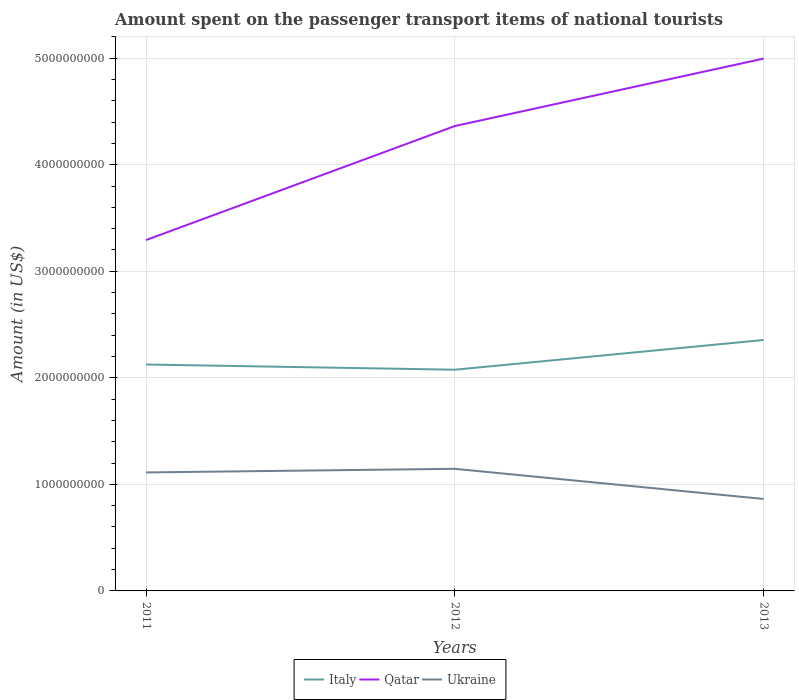How many different coloured lines are there?
Your answer should be very brief. 3. Does the line corresponding to Ukraine intersect with the line corresponding to Italy?
Your answer should be compact. No. Across all years, what is the maximum amount spent on the passenger transport items of national tourists in Ukraine?
Provide a succinct answer. 8.63e+08. What is the total amount spent on the passenger transport items of national tourists in Italy in the graph?
Offer a very short reply. -2.30e+08. What is the difference between the highest and the second highest amount spent on the passenger transport items of national tourists in Italy?
Offer a very short reply. 2.79e+08. What is the difference between the highest and the lowest amount spent on the passenger transport items of national tourists in Italy?
Keep it short and to the point. 1. How many lines are there?
Offer a very short reply. 3. Does the graph contain any zero values?
Offer a very short reply. No. How many legend labels are there?
Your answer should be very brief. 3. What is the title of the graph?
Give a very brief answer. Amount spent on the passenger transport items of national tourists. What is the label or title of the X-axis?
Your answer should be compact. Years. What is the Amount (in US$) in Italy in 2011?
Your answer should be compact. 2.12e+09. What is the Amount (in US$) in Qatar in 2011?
Keep it short and to the point. 3.29e+09. What is the Amount (in US$) of Ukraine in 2011?
Make the answer very short. 1.11e+09. What is the Amount (in US$) in Italy in 2012?
Ensure brevity in your answer.  2.08e+09. What is the Amount (in US$) in Qatar in 2012?
Ensure brevity in your answer.  4.36e+09. What is the Amount (in US$) of Ukraine in 2012?
Offer a very short reply. 1.15e+09. What is the Amount (in US$) in Italy in 2013?
Offer a terse response. 2.36e+09. What is the Amount (in US$) of Qatar in 2013?
Offer a very short reply. 5.00e+09. What is the Amount (in US$) of Ukraine in 2013?
Your answer should be compact. 8.63e+08. Across all years, what is the maximum Amount (in US$) of Italy?
Provide a succinct answer. 2.36e+09. Across all years, what is the maximum Amount (in US$) in Qatar?
Ensure brevity in your answer.  5.00e+09. Across all years, what is the maximum Amount (in US$) in Ukraine?
Offer a terse response. 1.15e+09. Across all years, what is the minimum Amount (in US$) in Italy?
Make the answer very short. 2.08e+09. Across all years, what is the minimum Amount (in US$) of Qatar?
Make the answer very short. 3.29e+09. Across all years, what is the minimum Amount (in US$) of Ukraine?
Keep it short and to the point. 8.63e+08. What is the total Amount (in US$) of Italy in the graph?
Give a very brief answer. 6.56e+09. What is the total Amount (in US$) in Qatar in the graph?
Provide a succinct answer. 1.27e+1. What is the total Amount (in US$) of Ukraine in the graph?
Keep it short and to the point. 3.12e+09. What is the difference between the Amount (in US$) of Italy in 2011 and that in 2012?
Ensure brevity in your answer.  4.90e+07. What is the difference between the Amount (in US$) in Qatar in 2011 and that in 2012?
Make the answer very short. -1.07e+09. What is the difference between the Amount (in US$) of Ukraine in 2011 and that in 2012?
Your response must be concise. -3.40e+07. What is the difference between the Amount (in US$) in Italy in 2011 and that in 2013?
Make the answer very short. -2.30e+08. What is the difference between the Amount (in US$) in Qatar in 2011 and that in 2013?
Offer a very short reply. -1.70e+09. What is the difference between the Amount (in US$) in Ukraine in 2011 and that in 2013?
Ensure brevity in your answer.  2.49e+08. What is the difference between the Amount (in US$) in Italy in 2012 and that in 2013?
Give a very brief answer. -2.79e+08. What is the difference between the Amount (in US$) of Qatar in 2012 and that in 2013?
Provide a short and direct response. -6.33e+08. What is the difference between the Amount (in US$) in Ukraine in 2012 and that in 2013?
Make the answer very short. 2.83e+08. What is the difference between the Amount (in US$) of Italy in 2011 and the Amount (in US$) of Qatar in 2012?
Make the answer very short. -2.24e+09. What is the difference between the Amount (in US$) of Italy in 2011 and the Amount (in US$) of Ukraine in 2012?
Your answer should be very brief. 9.79e+08. What is the difference between the Amount (in US$) in Qatar in 2011 and the Amount (in US$) in Ukraine in 2012?
Keep it short and to the point. 2.15e+09. What is the difference between the Amount (in US$) of Italy in 2011 and the Amount (in US$) of Qatar in 2013?
Keep it short and to the point. -2.87e+09. What is the difference between the Amount (in US$) in Italy in 2011 and the Amount (in US$) in Ukraine in 2013?
Your answer should be compact. 1.26e+09. What is the difference between the Amount (in US$) of Qatar in 2011 and the Amount (in US$) of Ukraine in 2013?
Offer a terse response. 2.43e+09. What is the difference between the Amount (in US$) of Italy in 2012 and the Amount (in US$) of Qatar in 2013?
Keep it short and to the point. -2.92e+09. What is the difference between the Amount (in US$) of Italy in 2012 and the Amount (in US$) of Ukraine in 2013?
Keep it short and to the point. 1.21e+09. What is the difference between the Amount (in US$) of Qatar in 2012 and the Amount (in US$) of Ukraine in 2013?
Offer a terse response. 3.50e+09. What is the average Amount (in US$) of Italy per year?
Provide a succinct answer. 2.19e+09. What is the average Amount (in US$) in Qatar per year?
Offer a very short reply. 4.22e+09. What is the average Amount (in US$) of Ukraine per year?
Your answer should be compact. 1.04e+09. In the year 2011, what is the difference between the Amount (in US$) in Italy and Amount (in US$) in Qatar?
Provide a short and direct response. -1.17e+09. In the year 2011, what is the difference between the Amount (in US$) in Italy and Amount (in US$) in Ukraine?
Provide a short and direct response. 1.01e+09. In the year 2011, what is the difference between the Amount (in US$) of Qatar and Amount (in US$) of Ukraine?
Keep it short and to the point. 2.18e+09. In the year 2012, what is the difference between the Amount (in US$) in Italy and Amount (in US$) in Qatar?
Your answer should be compact. -2.29e+09. In the year 2012, what is the difference between the Amount (in US$) in Italy and Amount (in US$) in Ukraine?
Give a very brief answer. 9.30e+08. In the year 2012, what is the difference between the Amount (in US$) of Qatar and Amount (in US$) of Ukraine?
Your answer should be compact. 3.22e+09. In the year 2013, what is the difference between the Amount (in US$) in Italy and Amount (in US$) in Qatar?
Your answer should be compact. -2.64e+09. In the year 2013, what is the difference between the Amount (in US$) in Italy and Amount (in US$) in Ukraine?
Keep it short and to the point. 1.49e+09. In the year 2013, what is the difference between the Amount (in US$) of Qatar and Amount (in US$) of Ukraine?
Make the answer very short. 4.13e+09. What is the ratio of the Amount (in US$) in Italy in 2011 to that in 2012?
Your answer should be very brief. 1.02. What is the ratio of the Amount (in US$) in Qatar in 2011 to that in 2012?
Ensure brevity in your answer.  0.75. What is the ratio of the Amount (in US$) in Ukraine in 2011 to that in 2012?
Provide a short and direct response. 0.97. What is the ratio of the Amount (in US$) of Italy in 2011 to that in 2013?
Offer a terse response. 0.9. What is the ratio of the Amount (in US$) in Qatar in 2011 to that in 2013?
Keep it short and to the point. 0.66. What is the ratio of the Amount (in US$) in Ukraine in 2011 to that in 2013?
Your answer should be compact. 1.29. What is the ratio of the Amount (in US$) of Italy in 2012 to that in 2013?
Your answer should be very brief. 0.88. What is the ratio of the Amount (in US$) in Qatar in 2012 to that in 2013?
Keep it short and to the point. 0.87. What is the ratio of the Amount (in US$) of Ukraine in 2012 to that in 2013?
Offer a very short reply. 1.33. What is the difference between the highest and the second highest Amount (in US$) in Italy?
Your response must be concise. 2.30e+08. What is the difference between the highest and the second highest Amount (in US$) in Qatar?
Your response must be concise. 6.33e+08. What is the difference between the highest and the second highest Amount (in US$) of Ukraine?
Offer a terse response. 3.40e+07. What is the difference between the highest and the lowest Amount (in US$) in Italy?
Keep it short and to the point. 2.79e+08. What is the difference between the highest and the lowest Amount (in US$) of Qatar?
Provide a succinct answer. 1.70e+09. What is the difference between the highest and the lowest Amount (in US$) of Ukraine?
Your answer should be very brief. 2.83e+08. 